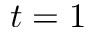Convert formula to latex. <formula><loc_0><loc_0><loc_500><loc_500>t = 1</formula> 